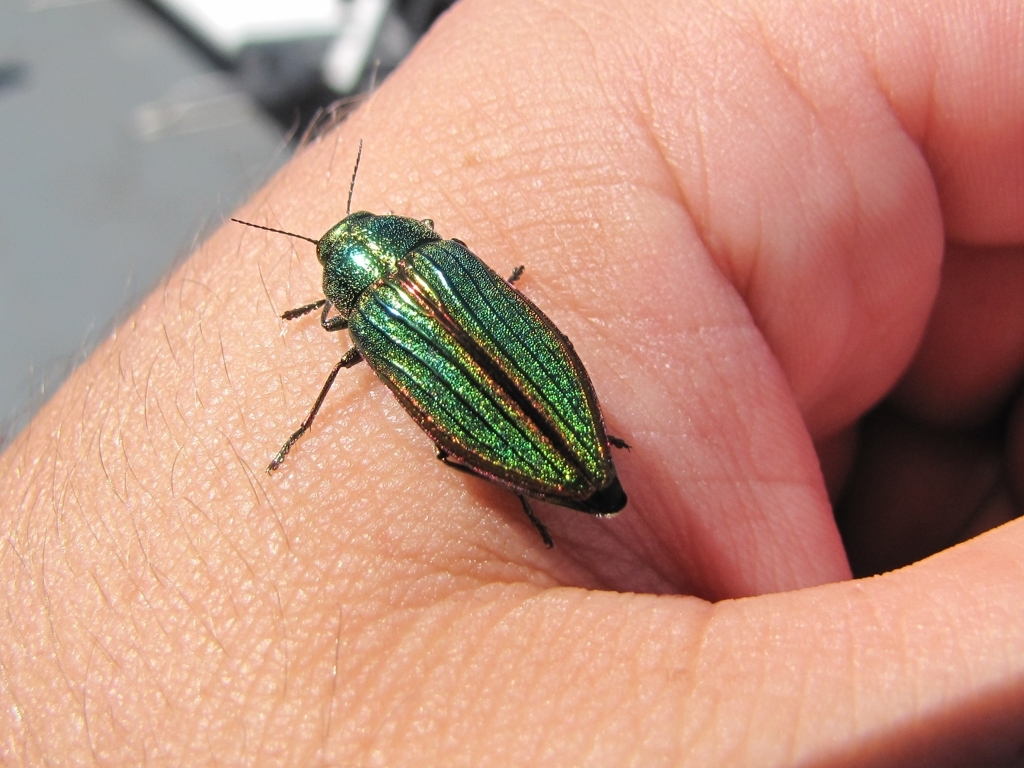What would be the consequences for the environment if this species were to disappear? The disappearance of this species could disrupt local ecosystems. As many insects are pollinators or a source of food for other animals, their loss could lead to reduced plant pollination and a decline in the populations of insectivorous species, potentially causing a cascade of ecological imbalance. 